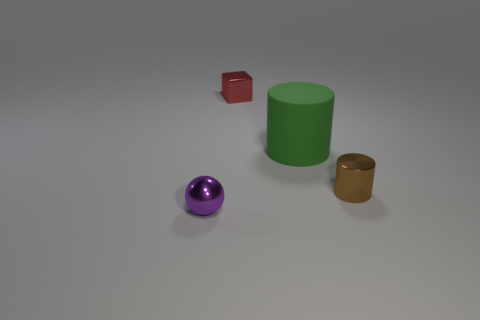Subtract all blue cylinders. Subtract all cyan cubes. How many cylinders are left? 2 Add 4 rubber cylinders. How many objects exist? 8 Subtract all balls. How many objects are left? 3 Subtract 1 red blocks. How many objects are left? 3 Subtract all tiny green metallic cylinders. Subtract all tiny purple shiny things. How many objects are left? 3 Add 3 small objects. How many small objects are left? 6 Add 3 metallic cubes. How many metallic cubes exist? 4 